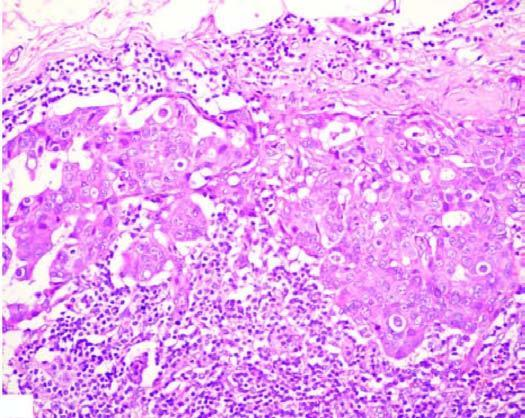what is surrounded by increased fat?
Answer the question using a single word or phrase. Matted mass of lymph nodes 